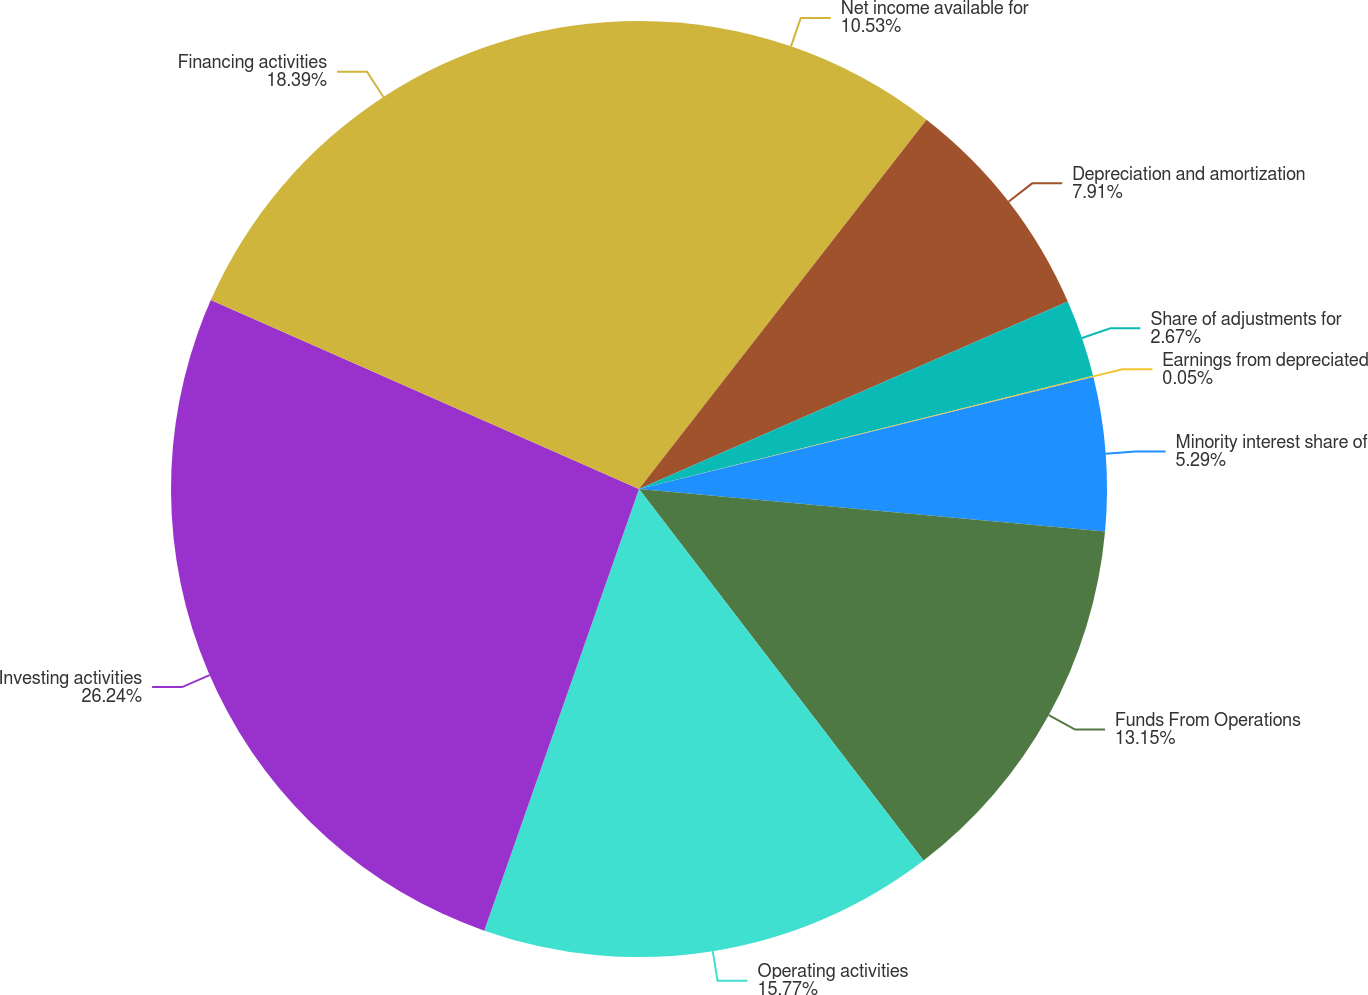Convert chart. <chart><loc_0><loc_0><loc_500><loc_500><pie_chart><fcel>Net income available for<fcel>Depreciation and amortization<fcel>Share of adjustments for<fcel>Earnings from depreciated<fcel>Minority interest share of<fcel>Funds From Operations<fcel>Operating activities<fcel>Investing activities<fcel>Financing activities<nl><fcel>10.53%<fcel>7.91%<fcel>2.67%<fcel>0.05%<fcel>5.29%<fcel>13.15%<fcel>15.77%<fcel>26.25%<fcel>18.39%<nl></chart> 